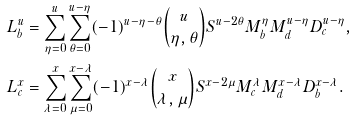Convert formula to latex. <formula><loc_0><loc_0><loc_500><loc_500>L _ { b } ^ { u } & = \sum _ { \eta = 0 } ^ { u } \sum _ { \theta = 0 } ^ { u - \eta } ( - 1 ) ^ { u - \eta - \theta } \binom { u } { \eta , \theta } S ^ { u - 2 \theta } M _ { b } ^ { \eta } M _ { d } ^ { u - \eta } D _ { c } ^ { u - \eta } , \\ L _ { c } ^ { x } & = \sum _ { \lambda = 0 } ^ { x } \sum _ { \mu = 0 } ^ { x - \lambda } ( - 1 ) ^ { x - \lambda } \binom { x } { \lambda , \mu } S ^ { x - 2 \mu } M _ { c } ^ { \lambda } M _ { d } ^ { x - \lambda } D _ { b } ^ { x - \lambda } .</formula> 